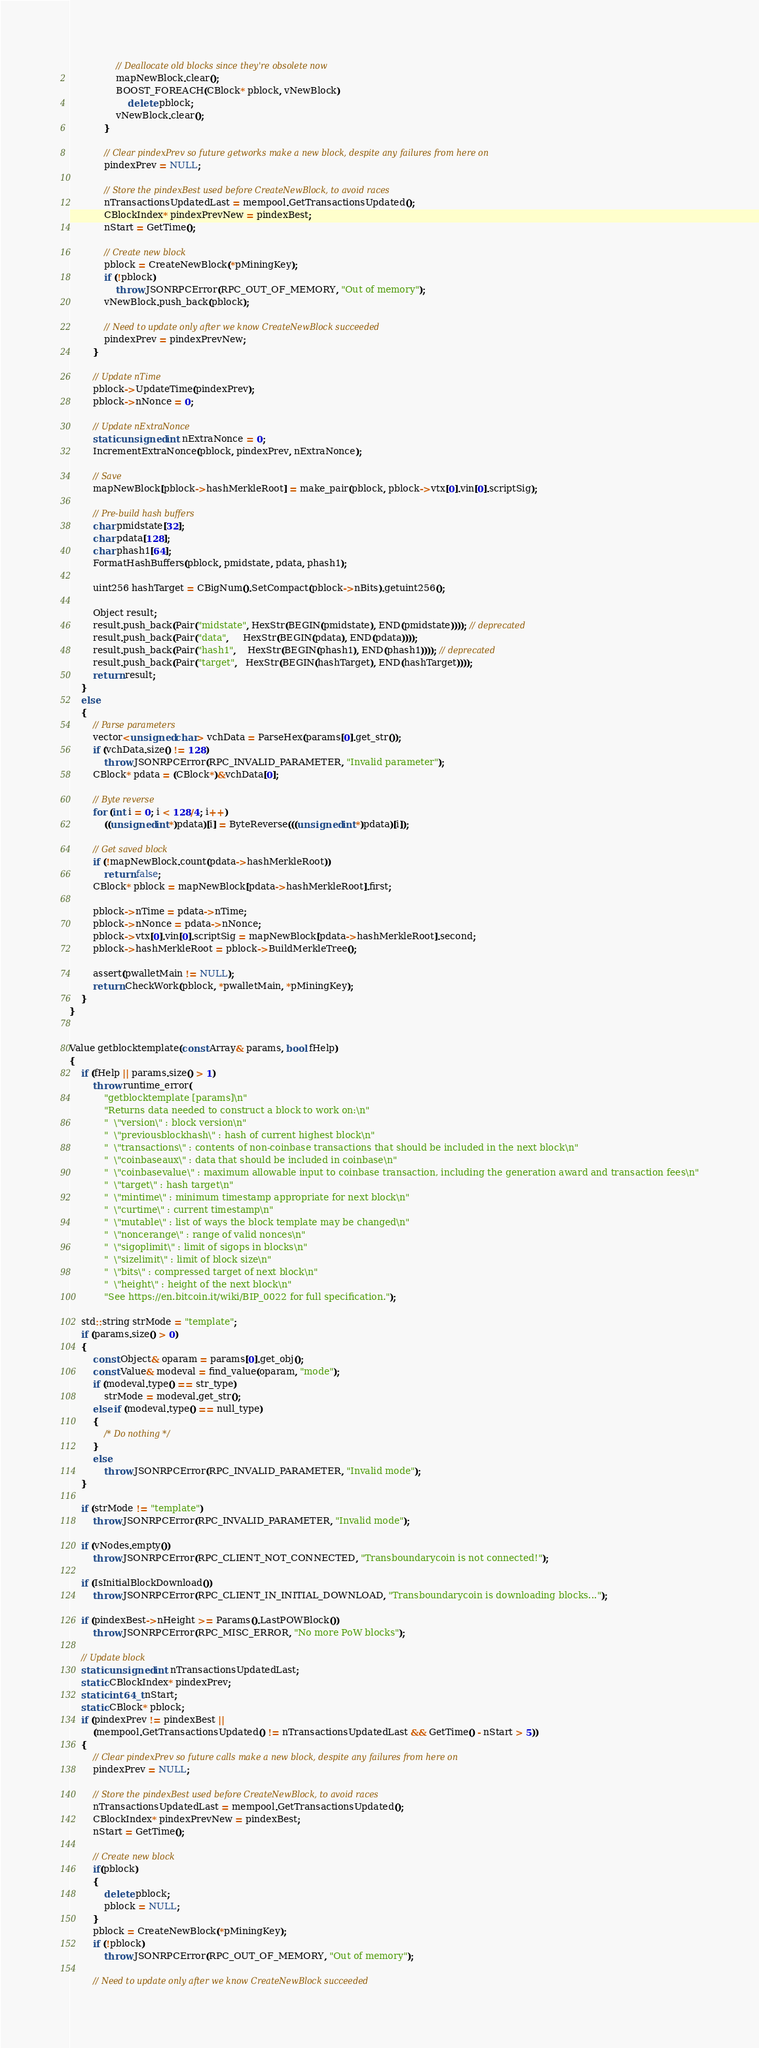Convert code to text. <code><loc_0><loc_0><loc_500><loc_500><_C++_>                // Deallocate old blocks since they're obsolete now
                mapNewBlock.clear();
                BOOST_FOREACH(CBlock* pblock, vNewBlock)
                    delete pblock;
                vNewBlock.clear();
            }

            // Clear pindexPrev so future getworks make a new block, despite any failures from here on
            pindexPrev = NULL;

            // Store the pindexBest used before CreateNewBlock, to avoid races
            nTransactionsUpdatedLast = mempool.GetTransactionsUpdated();
            CBlockIndex* pindexPrevNew = pindexBest;
            nStart = GetTime();

            // Create new block
            pblock = CreateNewBlock(*pMiningKey);
            if (!pblock)
                throw JSONRPCError(RPC_OUT_OF_MEMORY, "Out of memory");
            vNewBlock.push_back(pblock);

            // Need to update only after we know CreateNewBlock succeeded
            pindexPrev = pindexPrevNew;
        }

        // Update nTime
        pblock->UpdateTime(pindexPrev);
        pblock->nNonce = 0;

        // Update nExtraNonce
        static unsigned int nExtraNonce = 0;
        IncrementExtraNonce(pblock, pindexPrev, nExtraNonce);

        // Save
        mapNewBlock[pblock->hashMerkleRoot] = make_pair(pblock, pblock->vtx[0].vin[0].scriptSig);

        // Pre-build hash buffers
        char pmidstate[32];
        char pdata[128];
        char phash1[64];
        FormatHashBuffers(pblock, pmidstate, pdata, phash1);

        uint256 hashTarget = CBigNum().SetCompact(pblock->nBits).getuint256();

        Object result;
        result.push_back(Pair("midstate", HexStr(BEGIN(pmidstate), END(pmidstate)))); // deprecated
        result.push_back(Pair("data",     HexStr(BEGIN(pdata), END(pdata))));
        result.push_back(Pair("hash1",    HexStr(BEGIN(phash1), END(phash1)))); // deprecated
        result.push_back(Pair("target",   HexStr(BEGIN(hashTarget), END(hashTarget))));
        return result;
    }
    else
    {
        // Parse parameters
        vector<unsigned char> vchData = ParseHex(params[0].get_str());
        if (vchData.size() != 128)
            throw JSONRPCError(RPC_INVALID_PARAMETER, "Invalid parameter");
        CBlock* pdata = (CBlock*)&vchData[0];

        // Byte reverse
        for (int i = 0; i < 128/4; i++)
            ((unsigned int*)pdata)[i] = ByteReverse(((unsigned int*)pdata)[i]);

        // Get saved block
        if (!mapNewBlock.count(pdata->hashMerkleRoot))
            return false;
        CBlock* pblock = mapNewBlock[pdata->hashMerkleRoot].first;

        pblock->nTime = pdata->nTime;
        pblock->nNonce = pdata->nNonce;
        pblock->vtx[0].vin[0].scriptSig = mapNewBlock[pdata->hashMerkleRoot].second;
        pblock->hashMerkleRoot = pblock->BuildMerkleTree();

        assert(pwalletMain != NULL);
        return CheckWork(pblock, *pwalletMain, *pMiningKey);
    }
}


Value getblocktemplate(const Array& params, bool fHelp)
{
    if (fHelp || params.size() > 1)
        throw runtime_error(
            "getblocktemplate [params]\n"
            "Returns data needed to construct a block to work on:\n"
            "  \"version\" : block version\n"
            "  \"previousblockhash\" : hash of current highest block\n"
            "  \"transactions\" : contents of non-coinbase transactions that should be included in the next block\n"
            "  \"coinbaseaux\" : data that should be included in coinbase\n"
            "  \"coinbasevalue\" : maximum allowable input to coinbase transaction, including the generation award and transaction fees\n"
            "  \"target\" : hash target\n"
            "  \"mintime\" : minimum timestamp appropriate for next block\n"
            "  \"curtime\" : current timestamp\n"
            "  \"mutable\" : list of ways the block template may be changed\n"
            "  \"noncerange\" : range of valid nonces\n"
            "  \"sigoplimit\" : limit of sigops in blocks\n"
            "  \"sizelimit\" : limit of block size\n"
            "  \"bits\" : compressed target of next block\n"
            "  \"height\" : height of the next block\n"
            "See https://en.bitcoin.it/wiki/BIP_0022 for full specification.");

    std::string strMode = "template";
    if (params.size() > 0)
    {
        const Object& oparam = params[0].get_obj();
        const Value& modeval = find_value(oparam, "mode");
        if (modeval.type() == str_type)
            strMode = modeval.get_str();
        else if (modeval.type() == null_type)
        {
            /* Do nothing */
        }
        else
            throw JSONRPCError(RPC_INVALID_PARAMETER, "Invalid mode");
    }

    if (strMode != "template")
        throw JSONRPCError(RPC_INVALID_PARAMETER, "Invalid mode");

    if (vNodes.empty())
        throw JSONRPCError(RPC_CLIENT_NOT_CONNECTED, "Transboundarycoin is not connected!");

    if (IsInitialBlockDownload())
        throw JSONRPCError(RPC_CLIENT_IN_INITIAL_DOWNLOAD, "Transboundarycoin is downloading blocks...");

    if (pindexBest->nHeight >= Params().LastPOWBlock())
        throw JSONRPCError(RPC_MISC_ERROR, "No more PoW blocks");

    // Update block
    static unsigned int nTransactionsUpdatedLast;
    static CBlockIndex* pindexPrev;
    static int64_t nStart;
    static CBlock* pblock;
    if (pindexPrev != pindexBest ||
        (mempool.GetTransactionsUpdated() != nTransactionsUpdatedLast && GetTime() - nStart > 5))
    {
        // Clear pindexPrev so future calls make a new block, despite any failures from here on
        pindexPrev = NULL;

        // Store the pindexBest used before CreateNewBlock, to avoid races
        nTransactionsUpdatedLast = mempool.GetTransactionsUpdated();
        CBlockIndex* pindexPrevNew = pindexBest;
        nStart = GetTime();

        // Create new block
        if(pblock)
        {
            delete pblock;
            pblock = NULL;
        }
        pblock = CreateNewBlock(*pMiningKey);
        if (!pblock)
            throw JSONRPCError(RPC_OUT_OF_MEMORY, "Out of memory");

        // Need to update only after we know CreateNewBlock succeeded</code> 